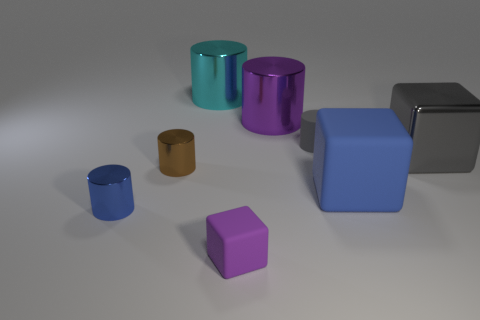There is a thing that is in front of the blue metallic object; is it the same color as the small cylinder that is to the right of the cyan cylinder?
Provide a succinct answer. No. Is there another tiny metal thing of the same shape as the purple metallic thing?
Ensure brevity in your answer.  Yes. What number of other objects are the same color as the tiny matte cylinder?
Ensure brevity in your answer.  1. What is the color of the large metal thing that is in front of the gray cylinder in front of the big shiny cylinder on the right side of the large cyan cylinder?
Make the answer very short. Gray. Is the number of gray rubber things that are in front of the tiny blue object the same as the number of large red rubber cylinders?
Your response must be concise. Yes. Do the purple object that is behind the purple rubber object and the large blue rubber object have the same size?
Your answer should be very brief. Yes. How many things are there?
Keep it short and to the point. 8. How many things are to the left of the blue rubber cube and behind the large blue cube?
Your answer should be compact. 4. Are there any large things made of the same material as the large blue cube?
Offer a very short reply. No. The cyan cylinder behind the matte cube that is on the left side of the big blue rubber block is made of what material?
Give a very brief answer. Metal. 